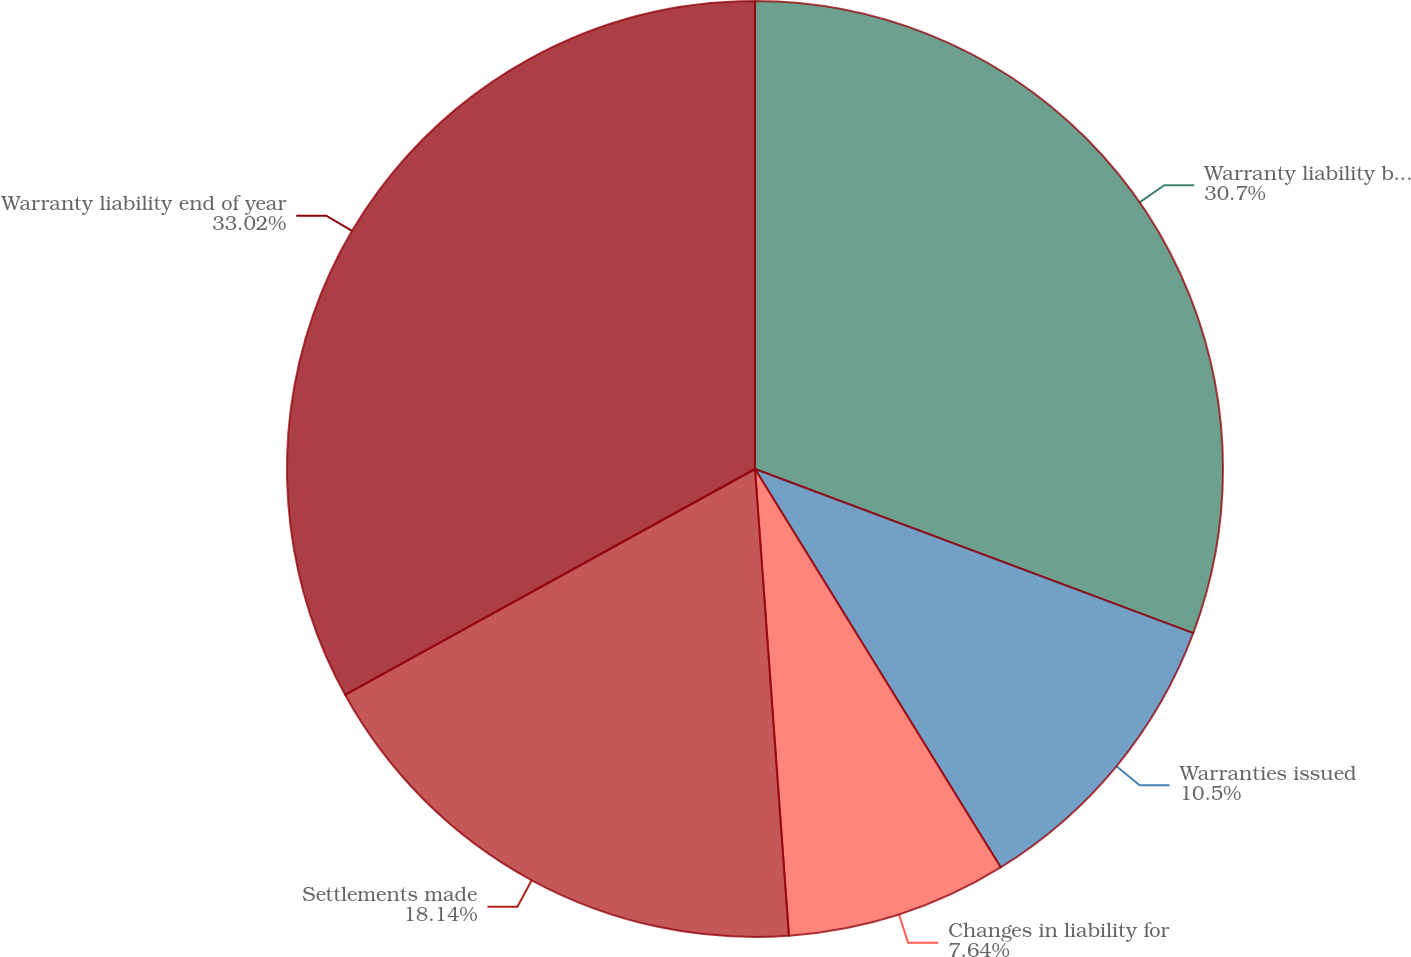Convert chart. <chart><loc_0><loc_0><loc_500><loc_500><pie_chart><fcel>Warranty liability beginning<fcel>Warranties issued<fcel>Changes in liability for<fcel>Settlements made<fcel>Warranty liability end of year<nl><fcel>30.7%<fcel>10.5%<fcel>7.64%<fcel>18.14%<fcel>33.01%<nl></chart> 